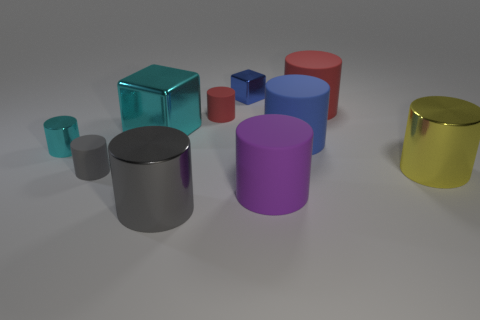Subtract all red cylinders. How many cylinders are left? 6 Subtract all cyan metallic cylinders. How many cylinders are left? 7 Subtract all blue cylinders. Subtract all cyan cubes. How many cylinders are left? 7 Subtract all blocks. How many objects are left? 8 Subtract all big gray shiny blocks. Subtract all tiny cyan metal objects. How many objects are left? 9 Add 6 gray matte objects. How many gray matte objects are left? 7 Add 9 big blue things. How many big blue things exist? 10 Subtract 0 cyan balls. How many objects are left? 10 